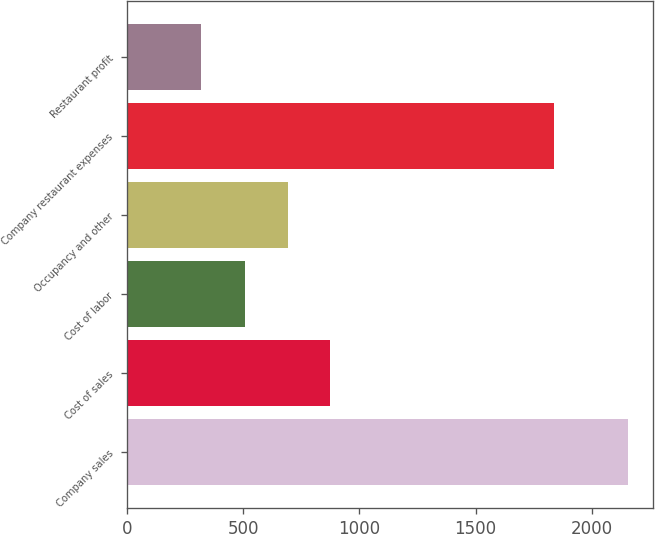Convert chart. <chart><loc_0><loc_0><loc_500><loc_500><bar_chart><fcel>Company sales<fcel>Cost of sales<fcel>Cost of labor<fcel>Occupancy and other<fcel>Company restaurant expenses<fcel>Restaurant profit<nl><fcel>2156<fcel>874.8<fcel>507<fcel>690.9<fcel>1839<fcel>317<nl></chart> 